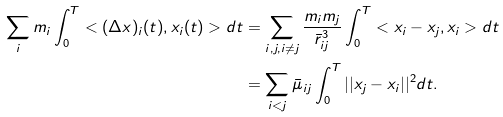Convert formula to latex. <formula><loc_0><loc_0><loc_500><loc_500>\sum _ { i } m _ { i } \int _ { 0 } ^ { T } < ( \Delta x ) _ { i } ( t ) , x _ { i } ( t ) > d t & = \sum _ { i , j , i \not = j } \frac { m _ { i } m _ { j } } { \bar { r } _ { i j } ^ { 3 } } \int _ { 0 } ^ { T } < x _ { i } - x _ { j } , x _ { i } > d t \\ & = \sum _ { i < j } \bar { \mu } _ { i j } \int _ { 0 } ^ { T } | | x _ { j } - x _ { i } | | ^ { 2 } d t .</formula> 